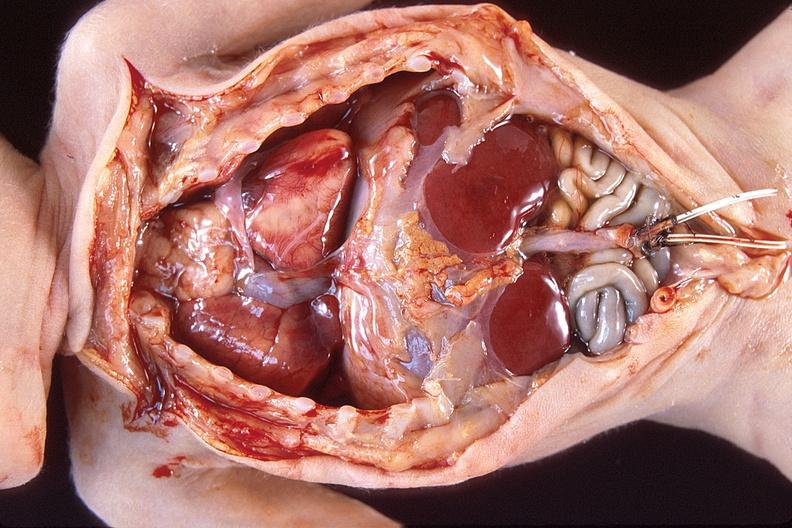does this image show hyaline membrane disease?
Answer the question using a single word or phrase. Yes 